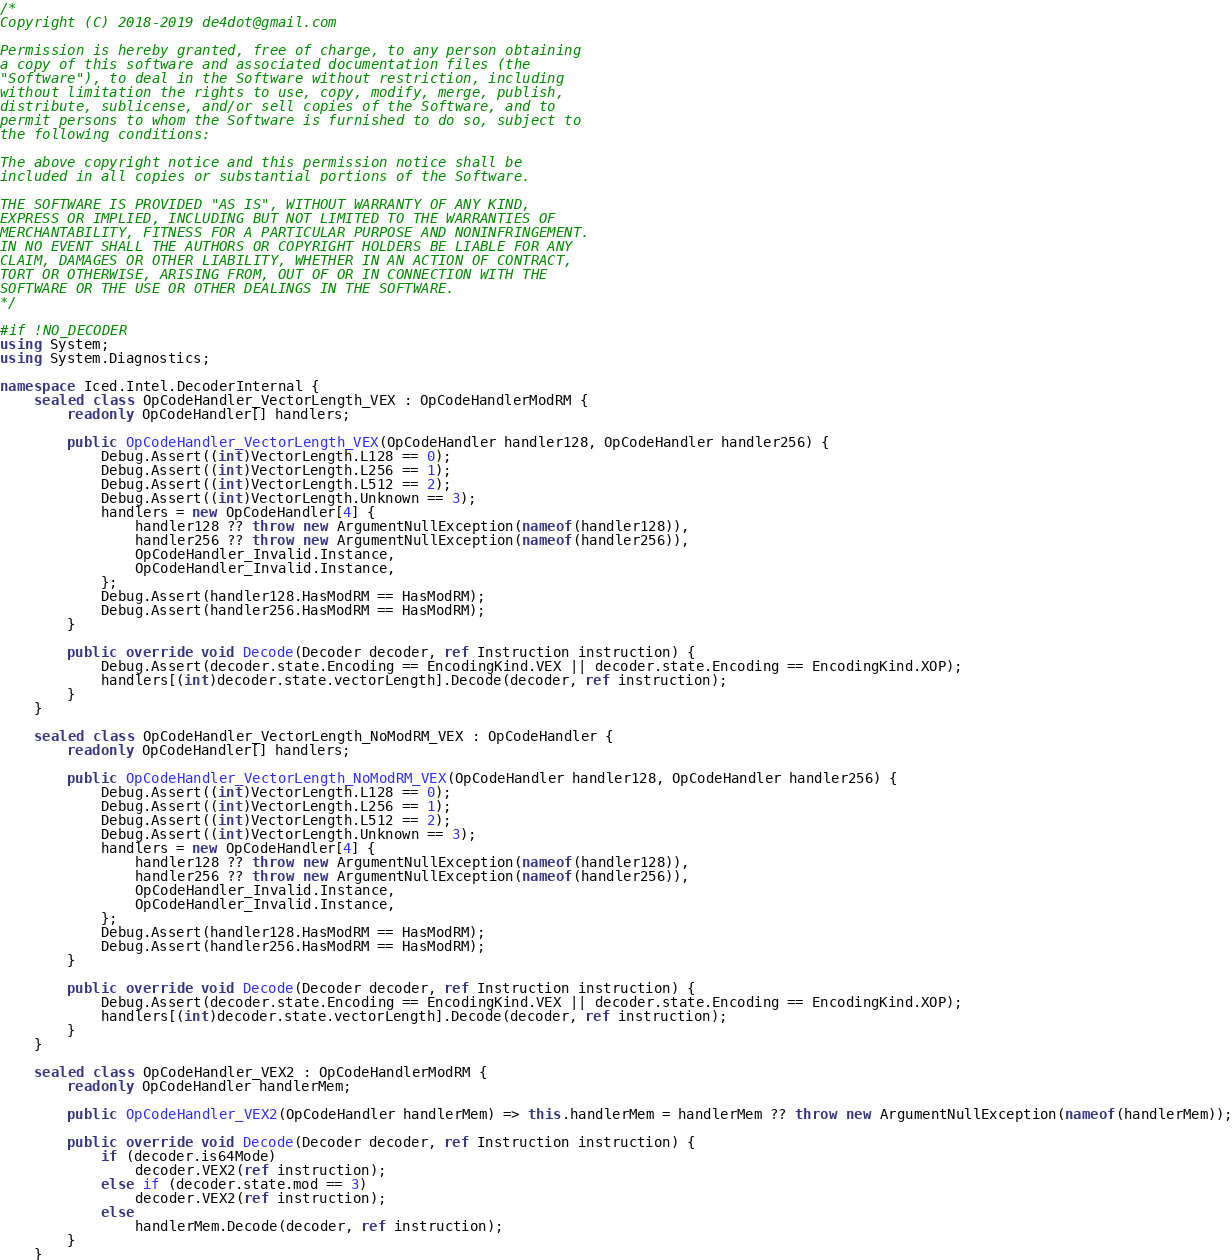<code> <loc_0><loc_0><loc_500><loc_500><_C#_>/*
Copyright (C) 2018-2019 de4dot@gmail.com

Permission is hereby granted, free of charge, to any person obtaining
a copy of this software and associated documentation files (the
"Software"), to deal in the Software without restriction, including
without limitation the rights to use, copy, modify, merge, publish,
distribute, sublicense, and/or sell copies of the Software, and to
permit persons to whom the Software is furnished to do so, subject to
the following conditions:

The above copyright notice and this permission notice shall be
included in all copies or substantial portions of the Software.

THE SOFTWARE IS PROVIDED "AS IS", WITHOUT WARRANTY OF ANY KIND,
EXPRESS OR IMPLIED, INCLUDING BUT NOT LIMITED TO THE WARRANTIES OF
MERCHANTABILITY, FITNESS FOR A PARTICULAR PURPOSE AND NONINFRINGEMENT.
IN NO EVENT SHALL THE AUTHORS OR COPYRIGHT HOLDERS BE LIABLE FOR ANY
CLAIM, DAMAGES OR OTHER LIABILITY, WHETHER IN AN ACTION OF CONTRACT,
TORT OR OTHERWISE, ARISING FROM, OUT OF OR IN CONNECTION WITH THE
SOFTWARE OR THE USE OR OTHER DEALINGS IN THE SOFTWARE.
*/

#if !NO_DECODER
using System;
using System.Diagnostics;

namespace Iced.Intel.DecoderInternal {
	sealed class OpCodeHandler_VectorLength_VEX : OpCodeHandlerModRM {
		readonly OpCodeHandler[] handlers;

		public OpCodeHandler_VectorLength_VEX(OpCodeHandler handler128, OpCodeHandler handler256) {
			Debug.Assert((int)VectorLength.L128 == 0);
			Debug.Assert((int)VectorLength.L256 == 1);
			Debug.Assert((int)VectorLength.L512 == 2);
			Debug.Assert((int)VectorLength.Unknown == 3);
			handlers = new OpCodeHandler[4] {
				handler128 ?? throw new ArgumentNullException(nameof(handler128)),
				handler256 ?? throw new ArgumentNullException(nameof(handler256)),
				OpCodeHandler_Invalid.Instance,
				OpCodeHandler_Invalid.Instance,
			};
			Debug.Assert(handler128.HasModRM == HasModRM);
			Debug.Assert(handler256.HasModRM == HasModRM);
		}

		public override void Decode(Decoder decoder, ref Instruction instruction) {
			Debug.Assert(decoder.state.Encoding == EncodingKind.VEX || decoder.state.Encoding == EncodingKind.XOP);
			handlers[(int)decoder.state.vectorLength].Decode(decoder, ref instruction);
		}
	}

	sealed class OpCodeHandler_VectorLength_NoModRM_VEX : OpCodeHandler {
		readonly OpCodeHandler[] handlers;

		public OpCodeHandler_VectorLength_NoModRM_VEX(OpCodeHandler handler128, OpCodeHandler handler256) {
			Debug.Assert((int)VectorLength.L128 == 0);
			Debug.Assert((int)VectorLength.L256 == 1);
			Debug.Assert((int)VectorLength.L512 == 2);
			Debug.Assert((int)VectorLength.Unknown == 3);
			handlers = new OpCodeHandler[4] {
				handler128 ?? throw new ArgumentNullException(nameof(handler128)),
				handler256 ?? throw new ArgumentNullException(nameof(handler256)),
				OpCodeHandler_Invalid.Instance,
				OpCodeHandler_Invalid.Instance,
			};
			Debug.Assert(handler128.HasModRM == HasModRM);
			Debug.Assert(handler256.HasModRM == HasModRM);
		}

		public override void Decode(Decoder decoder, ref Instruction instruction) {
			Debug.Assert(decoder.state.Encoding == EncodingKind.VEX || decoder.state.Encoding == EncodingKind.XOP);
			handlers[(int)decoder.state.vectorLength].Decode(decoder, ref instruction);
		}
	}

	sealed class OpCodeHandler_VEX2 : OpCodeHandlerModRM {
		readonly OpCodeHandler handlerMem;

		public OpCodeHandler_VEX2(OpCodeHandler handlerMem) => this.handlerMem = handlerMem ?? throw new ArgumentNullException(nameof(handlerMem));

		public override void Decode(Decoder decoder, ref Instruction instruction) {
			if (decoder.is64Mode)
				decoder.VEX2(ref instruction);
			else if (decoder.state.mod == 3)
				decoder.VEX2(ref instruction);
			else
				handlerMem.Decode(decoder, ref instruction);
		}
	}
</code> 